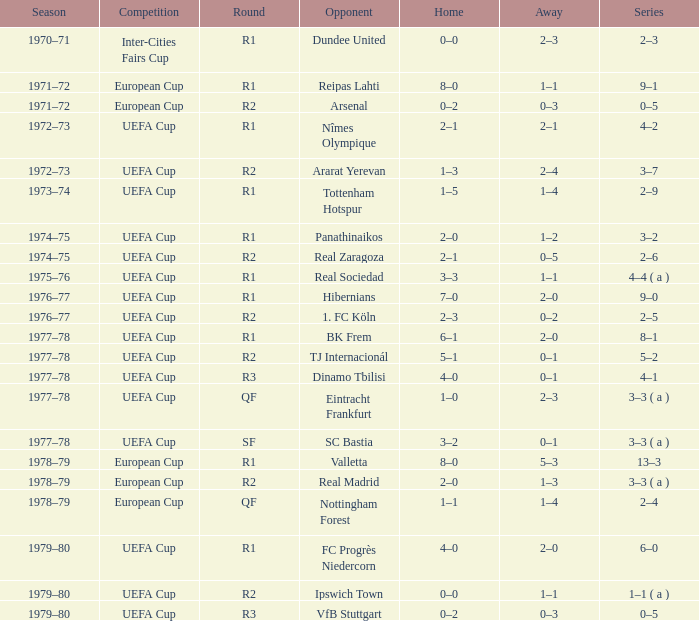In which season is there a rival for hibernians? 1976–77. 